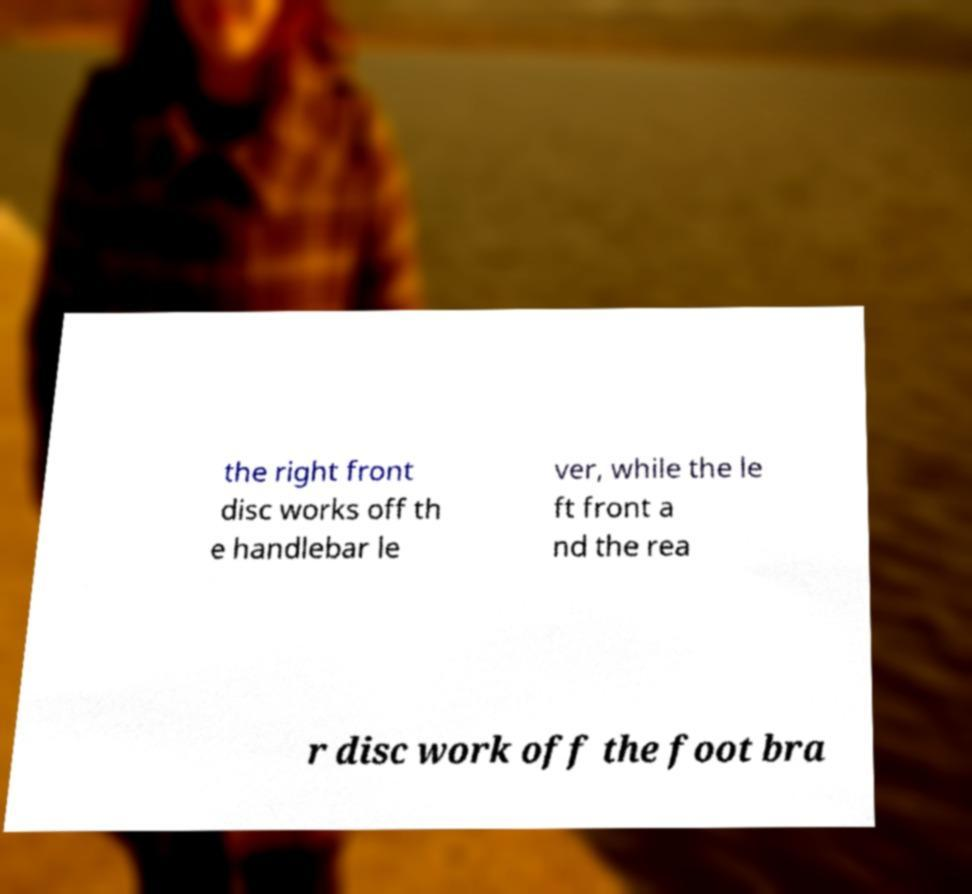Please identify and transcribe the text found in this image. the right front disc works off th e handlebar le ver, while the le ft front a nd the rea r disc work off the foot bra 